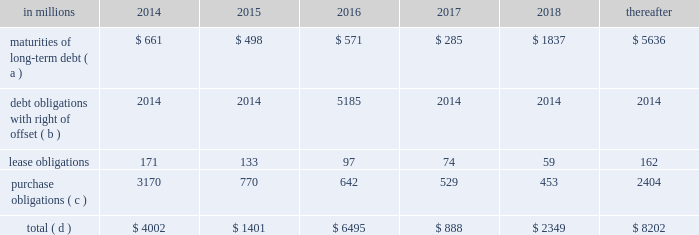Average cost of debt from 7.1% ( 7.1 % ) to an effective rate of 6.9% ( 6.9 % ) .
The inclusion of the offsetting interest income from short-term investments reduced this effective rate to 6.26% ( 6.26 % ) .
Other financing activities during 2011 included the issuance of approximately 0.3 million shares of treasury stock for various incentive plans and the acquisition of 1.0 million shares of treasury stock primarily related to restricted stock withholding taxes .
Payments of restricted stock withholding taxes totaled $ 30 million .
Off-balance sheet variable interest entities information concerning off-balance sheet variable interest entities is set forth in note 12 variable interest entities and preferred securities of subsidiaries on pages 72 through 75 of item 8 .
Financial statements and supplementary data for discussion .
Liquidity and capital resources outlook for 2014 capital expenditures and long-term debt international paper expects to be able to meet projected capital expenditures , service existing debt and meet working capital and dividend requirements during 2014 through current cash balances and cash from operations .
Additionally , the company has existing credit facilities totaling $ 2.0 billion .
The company was in compliance with all its debt covenants at december 31 , 2013 .
The company 2019s financial covenants require the maintenance of a minimum net worth of $ 9 billion and a total debt-to- capital ratio of less than 60% ( 60 % ) .
Net worth is defined as the sum of common stock , paid-in capital and retained earnings , less treasury stock plus any cumulative goodwill impairment charges .
The calculation also excludes accumulated other comprehensive income/ loss and nonrecourse financial liabilities of special purpose entities .
The total debt-to-capital ratio is defined as total debt divided by the sum of total debt plus net worth .
At december 31 , 2013 , international paper 2019s net worth was $ 15.1 billion , and the total-debt- to-capital ratio was 39% ( 39 % ) .
The company will continue to rely upon debt and capital markets for the majority of any necessary long-term funding not provided by operating cash flows .
Funding decisions will be guided by our capital structure planning objectives .
The primary goals of the company 2019s capital structure planning are to maximize financial flexibility and preserve liquidity while reducing interest expense .
The majority of international paper 2019s debt is accessed through global public capital markets where we have a wide base of investors .
Maintaining an investment grade credit rating is an important element of international paper 2019s financing strategy .
At december 31 , 2013 , the company held long-term credit ratings of bbb ( stable outlook ) and baa3 ( stable outlook ) by s&p and moody 2019s , respectively .
Contractual obligations for future payments under existing debt and lease commitments and purchase obligations at december 31 , 2013 , were as follows: .
( a ) total debt includes scheduled principal payments only .
( b ) represents debt obligations borrowed from non-consolidated variable interest entities for which international paper has , and intends to effect , a legal right to offset these obligations with investments held in the entities .
Accordingly , in its consolidated balance sheet at december 31 , 2013 , international paper has offset approximately $ 5.2 billion of interests in the entities against this $ 5.2 billion of debt obligations held by the entities ( see note 12 variable interest entities and preferred securities of subsidiaries on pages 72 through 75 in item 8 .
Financial statements and supplementary data ) .
( c ) includes $ 3.3 billion relating to fiber supply agreements entered into at the time of the 2006 transformation plan forestland sales and in conjunction with the 2008 acquisition of weyerhaeuser company 2019s containerboard , packaging and recycling business .
( d ) not included in the above table due to the uncertainty as to the amount and timing of the payment are unrecognized tax benefits of approximately $ 146 million .
We consider the undistributed earnings of our foreign subsidiaries as of december 31 , 2013 , to be indefinitely reinvested and , accordingly , no u.s .
Income taxes have been provided thereon .
As of december 31 , 2013 , the amount of cash associated with indefinitely reinvested foreign earnings was approximately $ 900 million .
We do not anticipate the need to repatriate funds to the united states to satisfy domestic liquidity needs arising in the ordinary course of business , including liquidity needs associated with our domestic debt service requirements .
Pension obligations and funding at december 31 , 2013 , the projected benefit obligation for the company 2019s u.s .
Defined benefit plans determined under u.s .
Gaap was approximately $ 2.2 billion higher than the fair value of plan assets .
Approximately $ 1.8 billion of this amount relates to plans that are subject to minimum funding requirements .
Under current irs funding rules , the calculation of minimum funding requirements differs from the calculation of the present value of plan benefits ( the projected benefit obligation ) for accounting purposes .
In december 2008 , the worker , retiree and employer recovery act of 2008 ( wera ) was passed by the u.s .
Congress which provided for pension funding relief and technical corrections .
Funding .
In 2015 what percentage of contractual obligations for future payments under existing debt and lease commitments and purchase obligations at december 31 , 2013 was attributable to maturities of long-term debt? 
Computations: (498 / 1401)
Answer: 0.35546. 